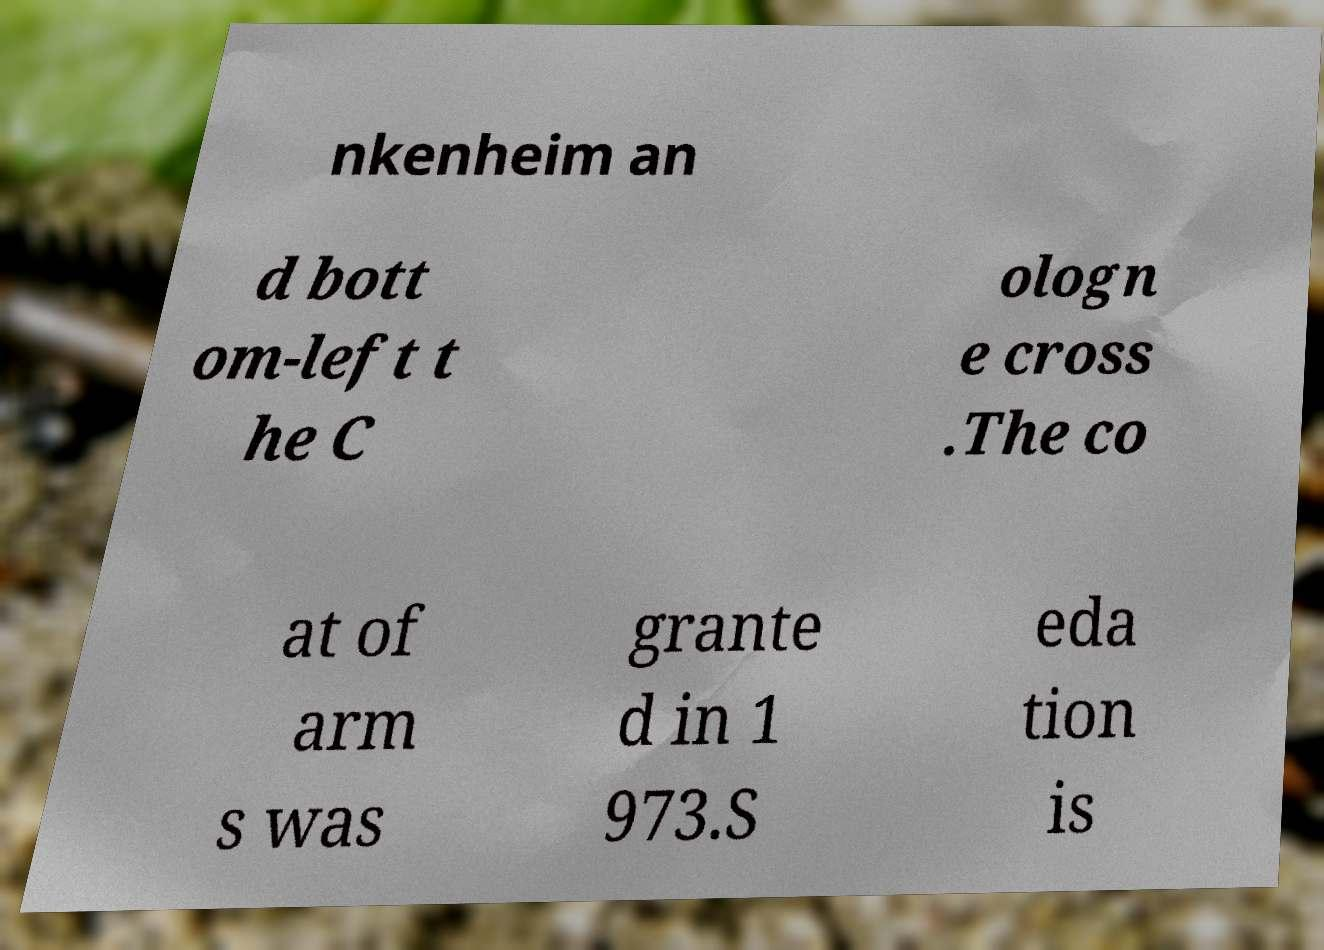Can you accurately transcribe the text from the provided image for me? nkenheim an d bott om-left t he C ologn e cross .The co at of arm s was grante d in 1 973.S eda tion is 